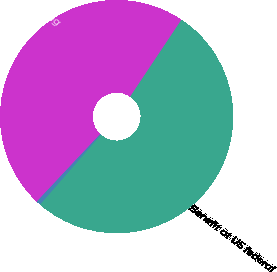<chart> <loc_0><loc_0><loc_500><loc_500><pie_chart><fcel>Benefit at US federal<fcel>Unbenefitted net operating<fcel>Other<nl><fcel>52.05%<fcel>47.36%<fcel>0.59%<nl></chart> 